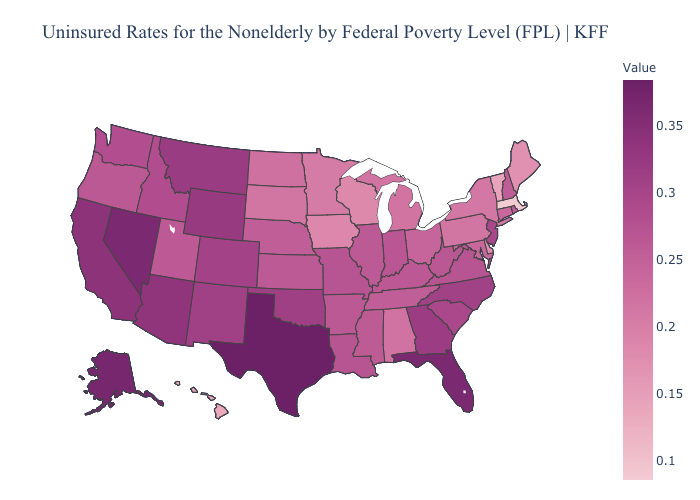Does Arkansas have a lower value than Texas?
Be succinct. Yes. Does the map have missing data?
Keep it brief. No. Does Delaware have the lowest value in the South?
Short answer required. Yes. Does North Dakota have the lowest value in the MidWest?
Quick response, please. No. Is the legend a continuous bar?
Write a very short answer. Yes. Does the map have missing data?
Answer briefly. No. Which states have the lowest value in the USA?
Concise answer only. Massachusetts. Which states hav the highest value in the South?
Be succinct. Texas. Does the map have missing data?
Answer briefly. No. 